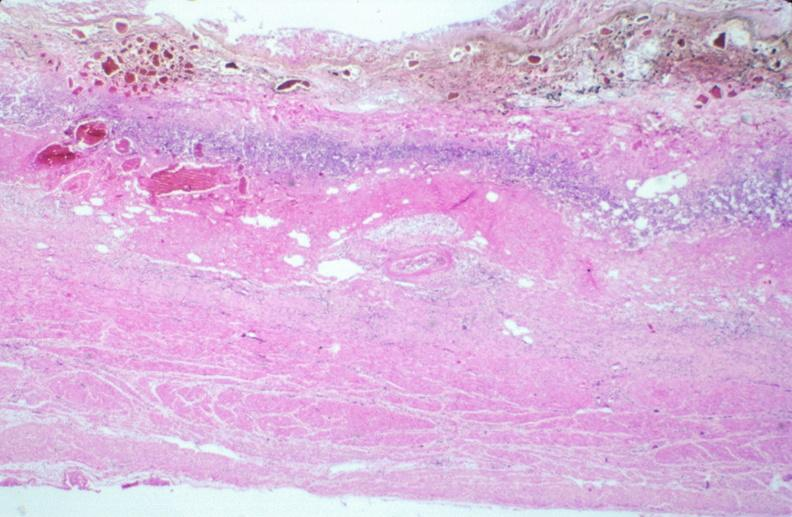does this image show stomach, necrotizing esophagitis and gastritis, sulfuric acid ingested as suicide attempt?
Answer the question using a single word or phrase. Yes 